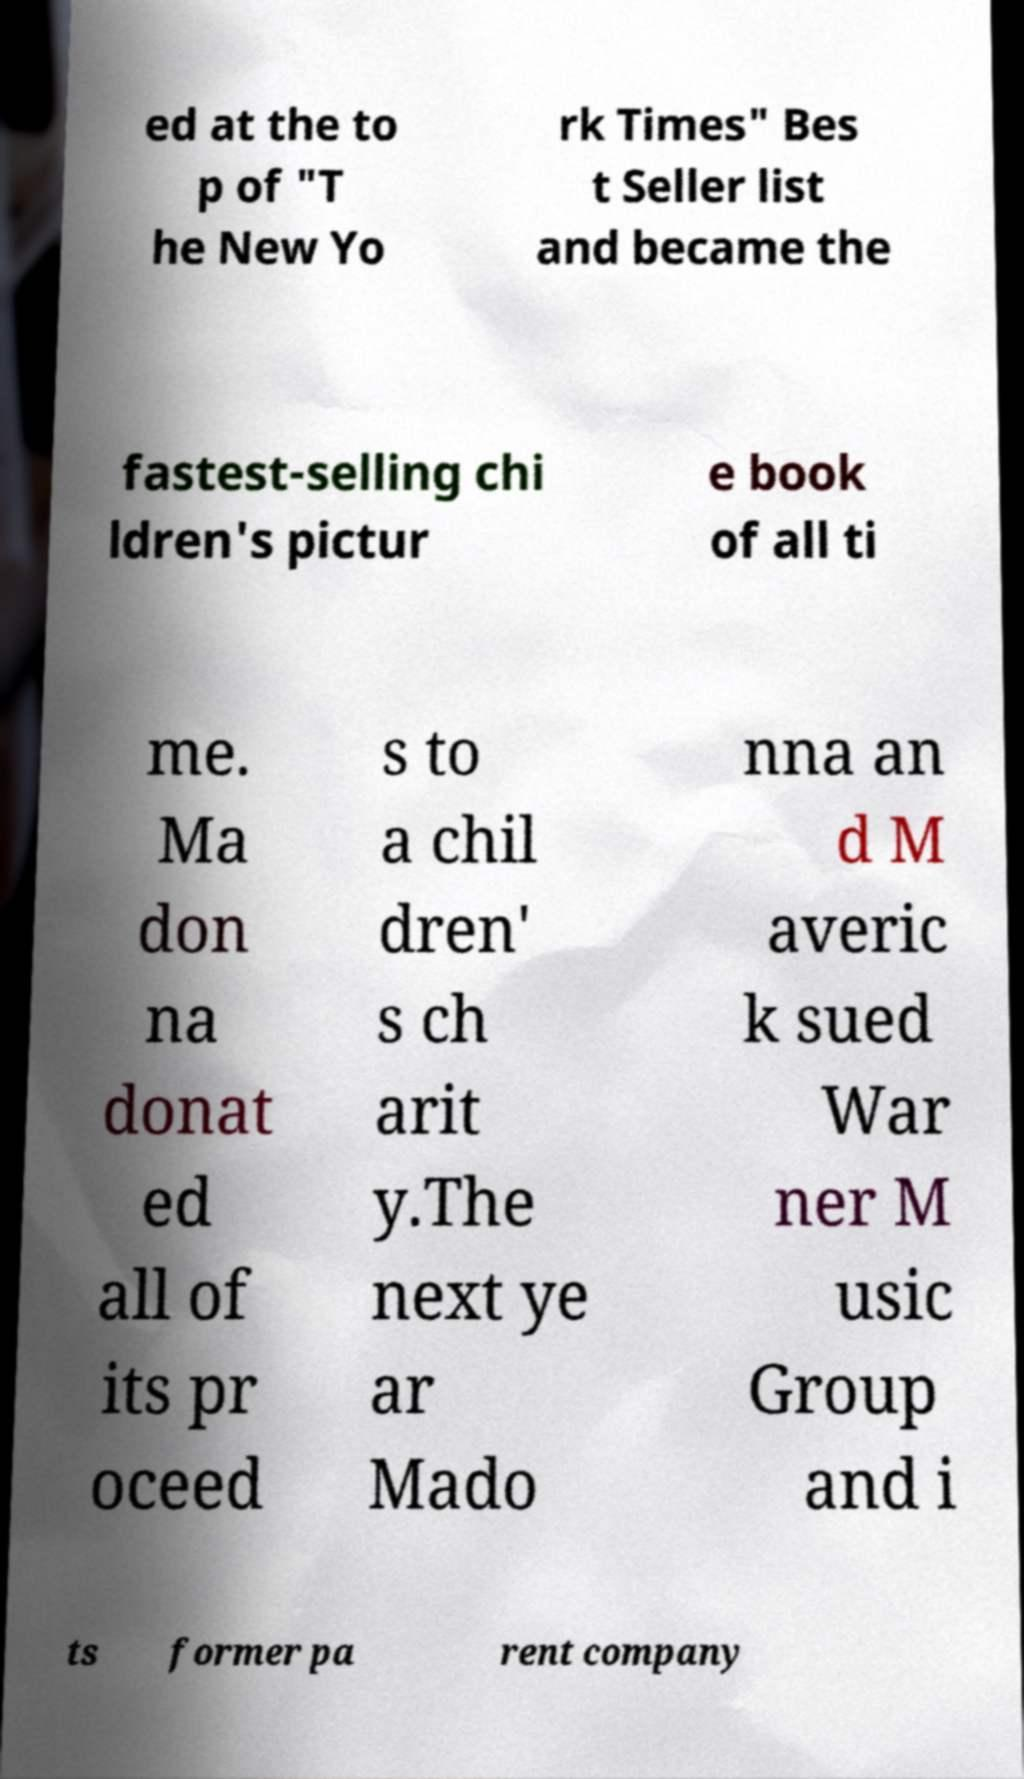For documentation purposes, I need the text within this image transcribed. Could you provide that? ed at the to p of "T he New Yo rk Times" Bes t Seller list and became the fastest-selling chi ldren's pictur e book of all ti me. Ma don na donat ed all of its pr oceed s to a chil dren' s ch arit y.The next ye ar Mado nna an d M averic k sued War ner M usic Group and i ts former pa rent company 